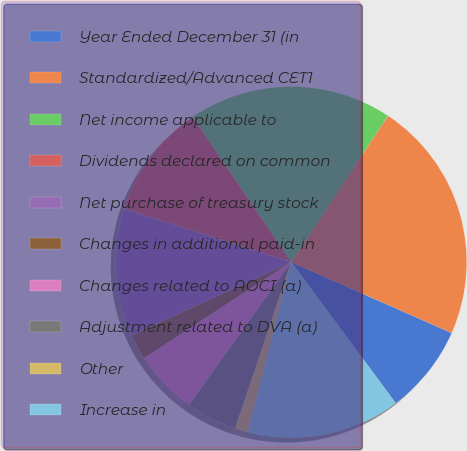<chart> <loc_0><loc_0><loc_500><loc_500><pie_chart><fcel>Year Ended December 31 (in<fcel>Standardized/Advanced CET1<fcel>Net income applicable to<fcel>Dividends declared on common<fcel>Net purchase of treasury stock<fcel>Changes in additional paid-in<fcel>Changes related to AOCI (a)<fcel>Adjustment related to DVA (a)<fcel>Other<fcel>Increase in<nl><fcel>8.24%<fcel>22.32%<fcel>18.8%<fcel>10.59%<fcel>11.76%<fcel>2.37%<fcel>5.89%<fcel>4.72%<fcel>1.2%<fcel>14.11%<nl></chart> 